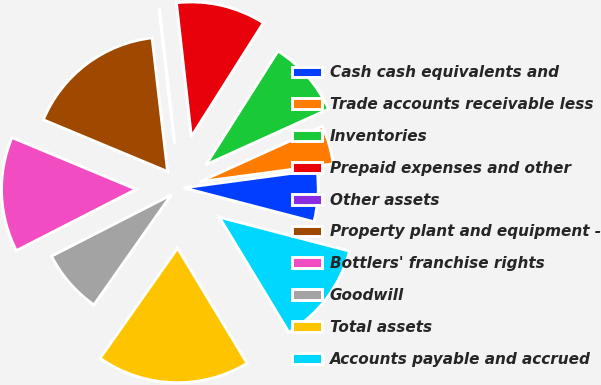Convert chart. <chart><loc_0><loc_0><loc_500><loc_500><pie_chart><fcel>Cash cash equivalents and<fcel>Trade accounts receivable less<fcel>Inventories<fcel>Prepaid expenses and other<fcel>Other assets<fcel>Property plant and equipment -<fcel>Bottlers' franchise rights<fcel>Goodwill<fcel>Total assets<fcel>Accounts payable and accrued<nl><fcel>6.18%<fcel>4.65%<fcel>9.24%<fcel>10.76%<fcel>0.06%<fcel>16.88%<fcel>13.82%<fcel>7.71%<fcel>18.41%<fcel>12.29%<nl></chart> 